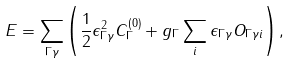Convert formula to latex. <formula><loc_0><loc_0><loc_500><loc_500>E = \sum _ { \Gamma \gamma } \left ( \frac { 1 } { 2 } \epsilon ^ { 2 } _ { \Gamma \gamma } C ^ { ( 0 ) } _ { \Gamma } + g _ { \Gamma } \sum _ { i } \epsilon _ { \Gamma \gamma } O _ { \Gamma \gamma i } \right ) ,</formula> 